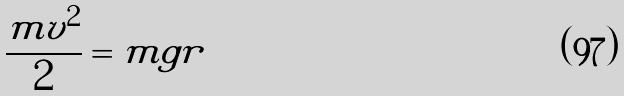<formula> <loc_0><loc_0><loc_500><loc_500>\frac { m v ^ { 2 } } { 2 } = m g r</formula> 